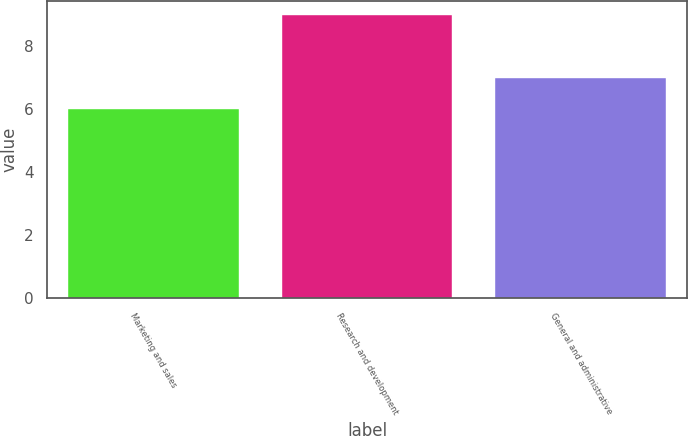Convert chart to OTSL. <chart><loc_0><loc_0><loc_500><loc_500><bar_chart><fcel>Marketing and sales<fcel>Research and development<fcel>General and administrative<nl><fcel>6<fcel>9<fcel>7<nl></chart> 